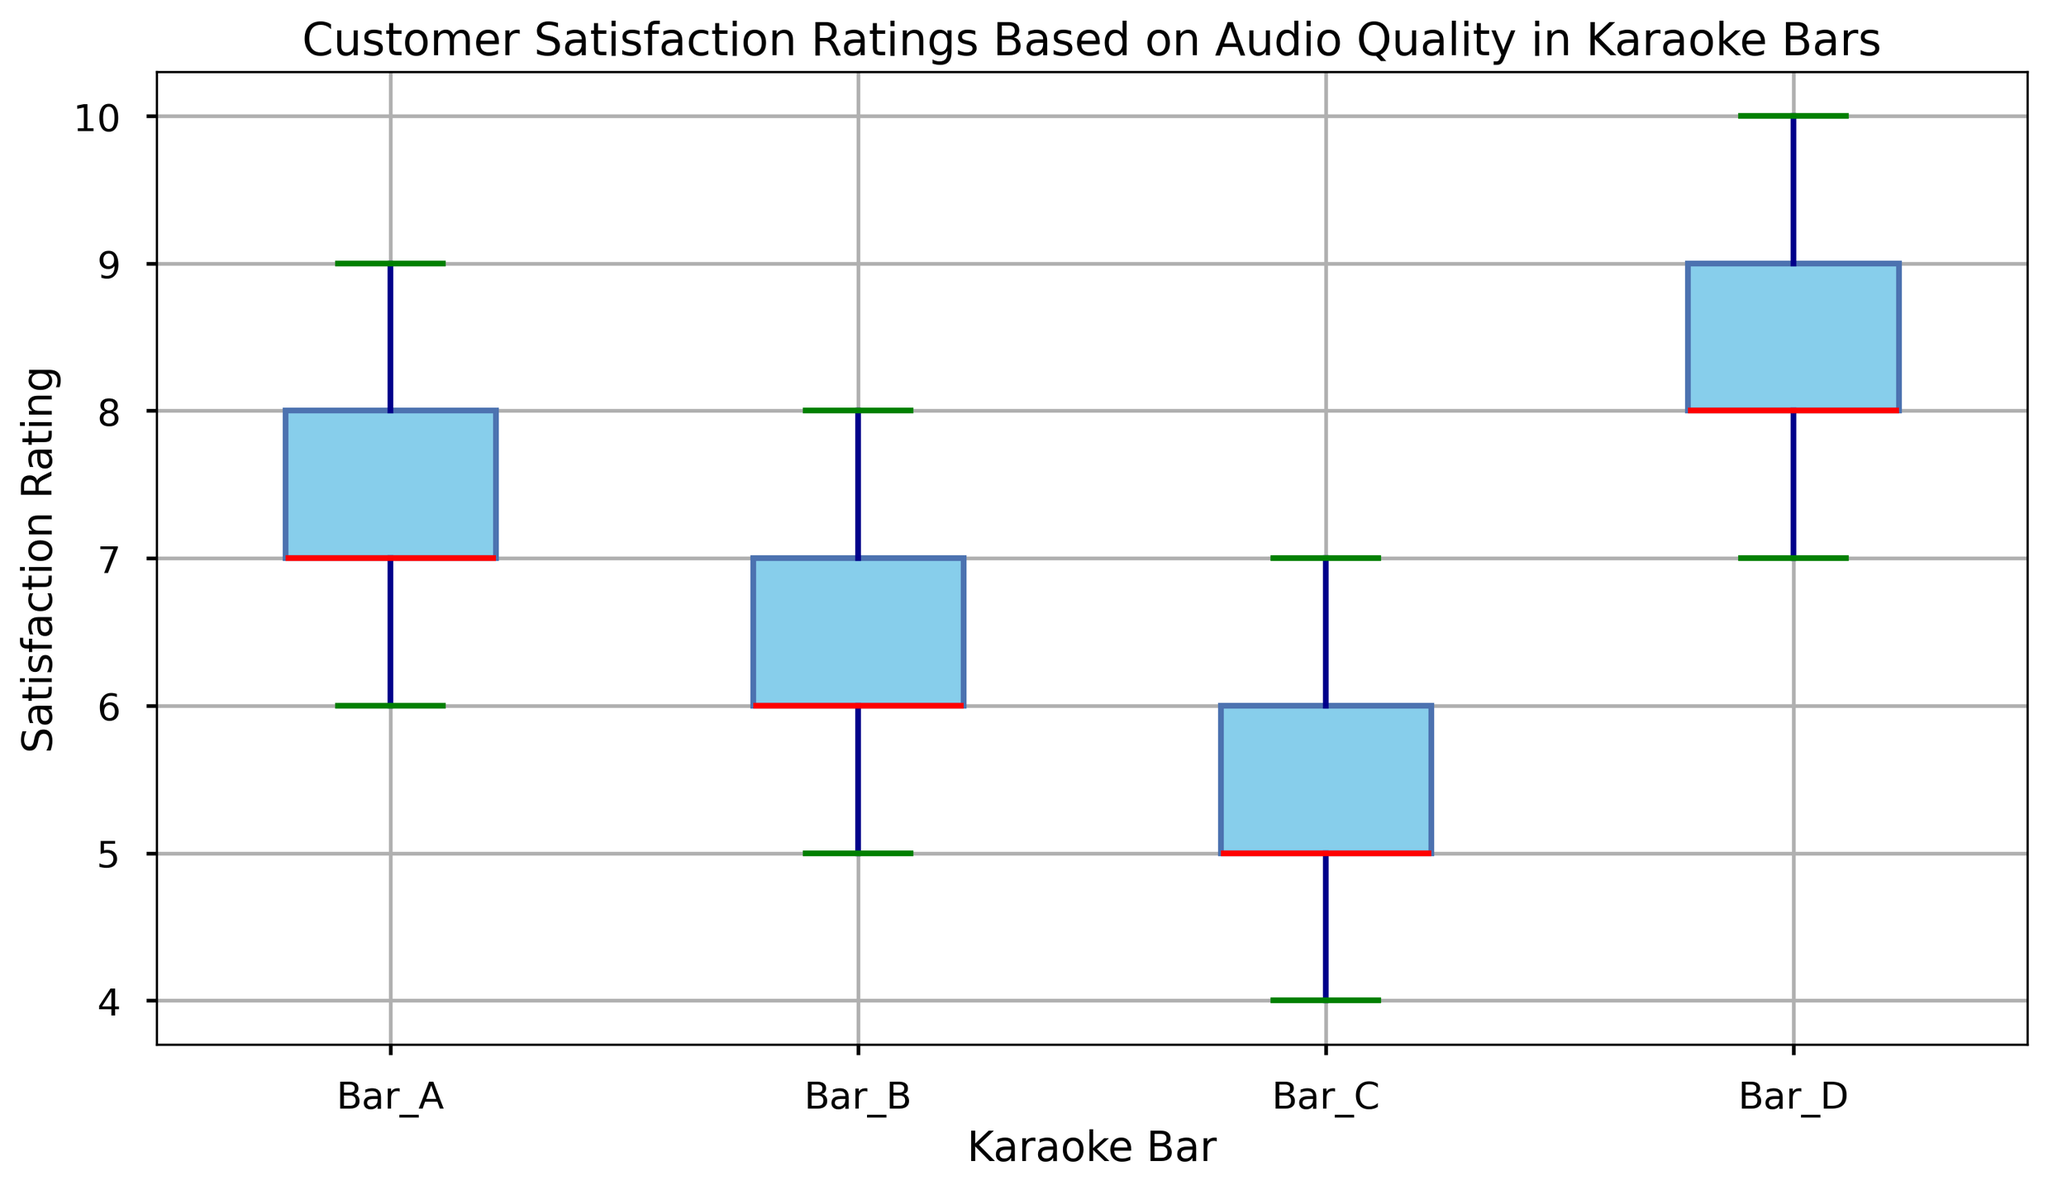How many outliers are there in each Karaoke Bar? To determine the number of outliers in each Karaoke bar, we need to look at the points outside the whiskers of each box plot. // Step-by-step: Bar_A has two visible outliers; Bar_B has none; Bar_C has none; Bar_D has none.
Answer: Bar_A: 2, Bar_B: 0, Bar_C: 0, Bar_D: 0 Which Karaoke Bar has the highest median customer satisfaction rating? The median is the line inside the box of each box plot. // Step-by-step: Locate the lines: for Bar_A, it's 7; for Bar_B, it's 6; for Bar_C, it's 5; for Bar_D, it's 8. The highest among them is Bar_D.
Answer: Bar_D Compare the interquartile ranges (IQR) for all Karaoke Bars and identify which has the widest range. The IQR is the height of the box, calculated as the difference between the third and first quartiles (Q3 - Q1). // Step-by-step: Observing the boxes, Bar_A's range appears smaller; Bar_B and Bar_C seem similar; Bar_D has a noticeably wider box.
Answer: Bar_D Which Karaoke Bar has the smallest variation in customer satisfaction ratings? Variation is visually represented by the spread of the box and whiskers. The smaller spread indicates lesser variation. // Step-by-step: Bar_A and Bar_D have a wider spread; Bar_B and Bar_C have smaller spreads, with Bar_B being the smallest.
Answer: Bar_B Are there any noticeable differences in the customer satisfaction ratings between Bar_A and Bar_C? To compare, examine the medians, IQRs, and overall spread. // Step-by-step: Bar_A has a median of 7 and a wider IQR; Bar_C has a median of 5 and a narrower IQR. Bar_A also has outliers whereas Bar_C doesn't.
Answer: Yes What is the median customer satisfaction rating for Bar_A? The median is represented by the line inside the box. // Step-by-step: For Bar_A, this line corresponds to 7.
Answer: 7 Considering both the median and outliers, which Karaoke Bar shows more consistency in customer satisfaction? Consistency can be inferred from both the median and the absence of outliers. A consistent bar would have a stable median and fewer or no outliers. // Step-by-step: Bar_A has outliers and median at 7; Bar_B has no outliers with a lower median; Bar_C has no outliers but a low median; Bar_D has no outliers and a higher median.
Answer: Bar_D What are the highest and lowest customer satisfaction ratings recorded in Bar_D? To determine this, look at the top and bottom whiskers of the box plot for Bar_D. // Step-by-step: The highest rating is at the top whisker (10), and the lowest rating is at the bottom whisker (7).
Answer: Highest: 10, Lowest: 7 What is the range of the customer satisfaction ratings for Bar_B? The range is the difference between the highest and lowest values. // Step-by-step: The highest value is 8 and the lowest is 5, so the range is 8 - 5.
Answer: 3 